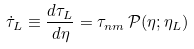<formula> <loc_0><loc_0><loc_500><loc_500>\dot { \tau } _ { L } \equiv \frac { d \tau _ { L } } { d \eta } = \tau _ { n m } \, \mathcal { P } ( \eta ; \eta _ { L } )</formula> 